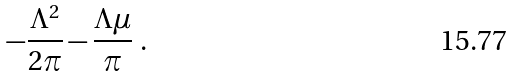Convert formula to latex. <formula><loc_0><loc_0><loc_500><loc_500>- \frac { \Lambda ^ { 2 } } { 2 \pi } - \frac { \Lambda \mu } { \pi } \ .</formula> 